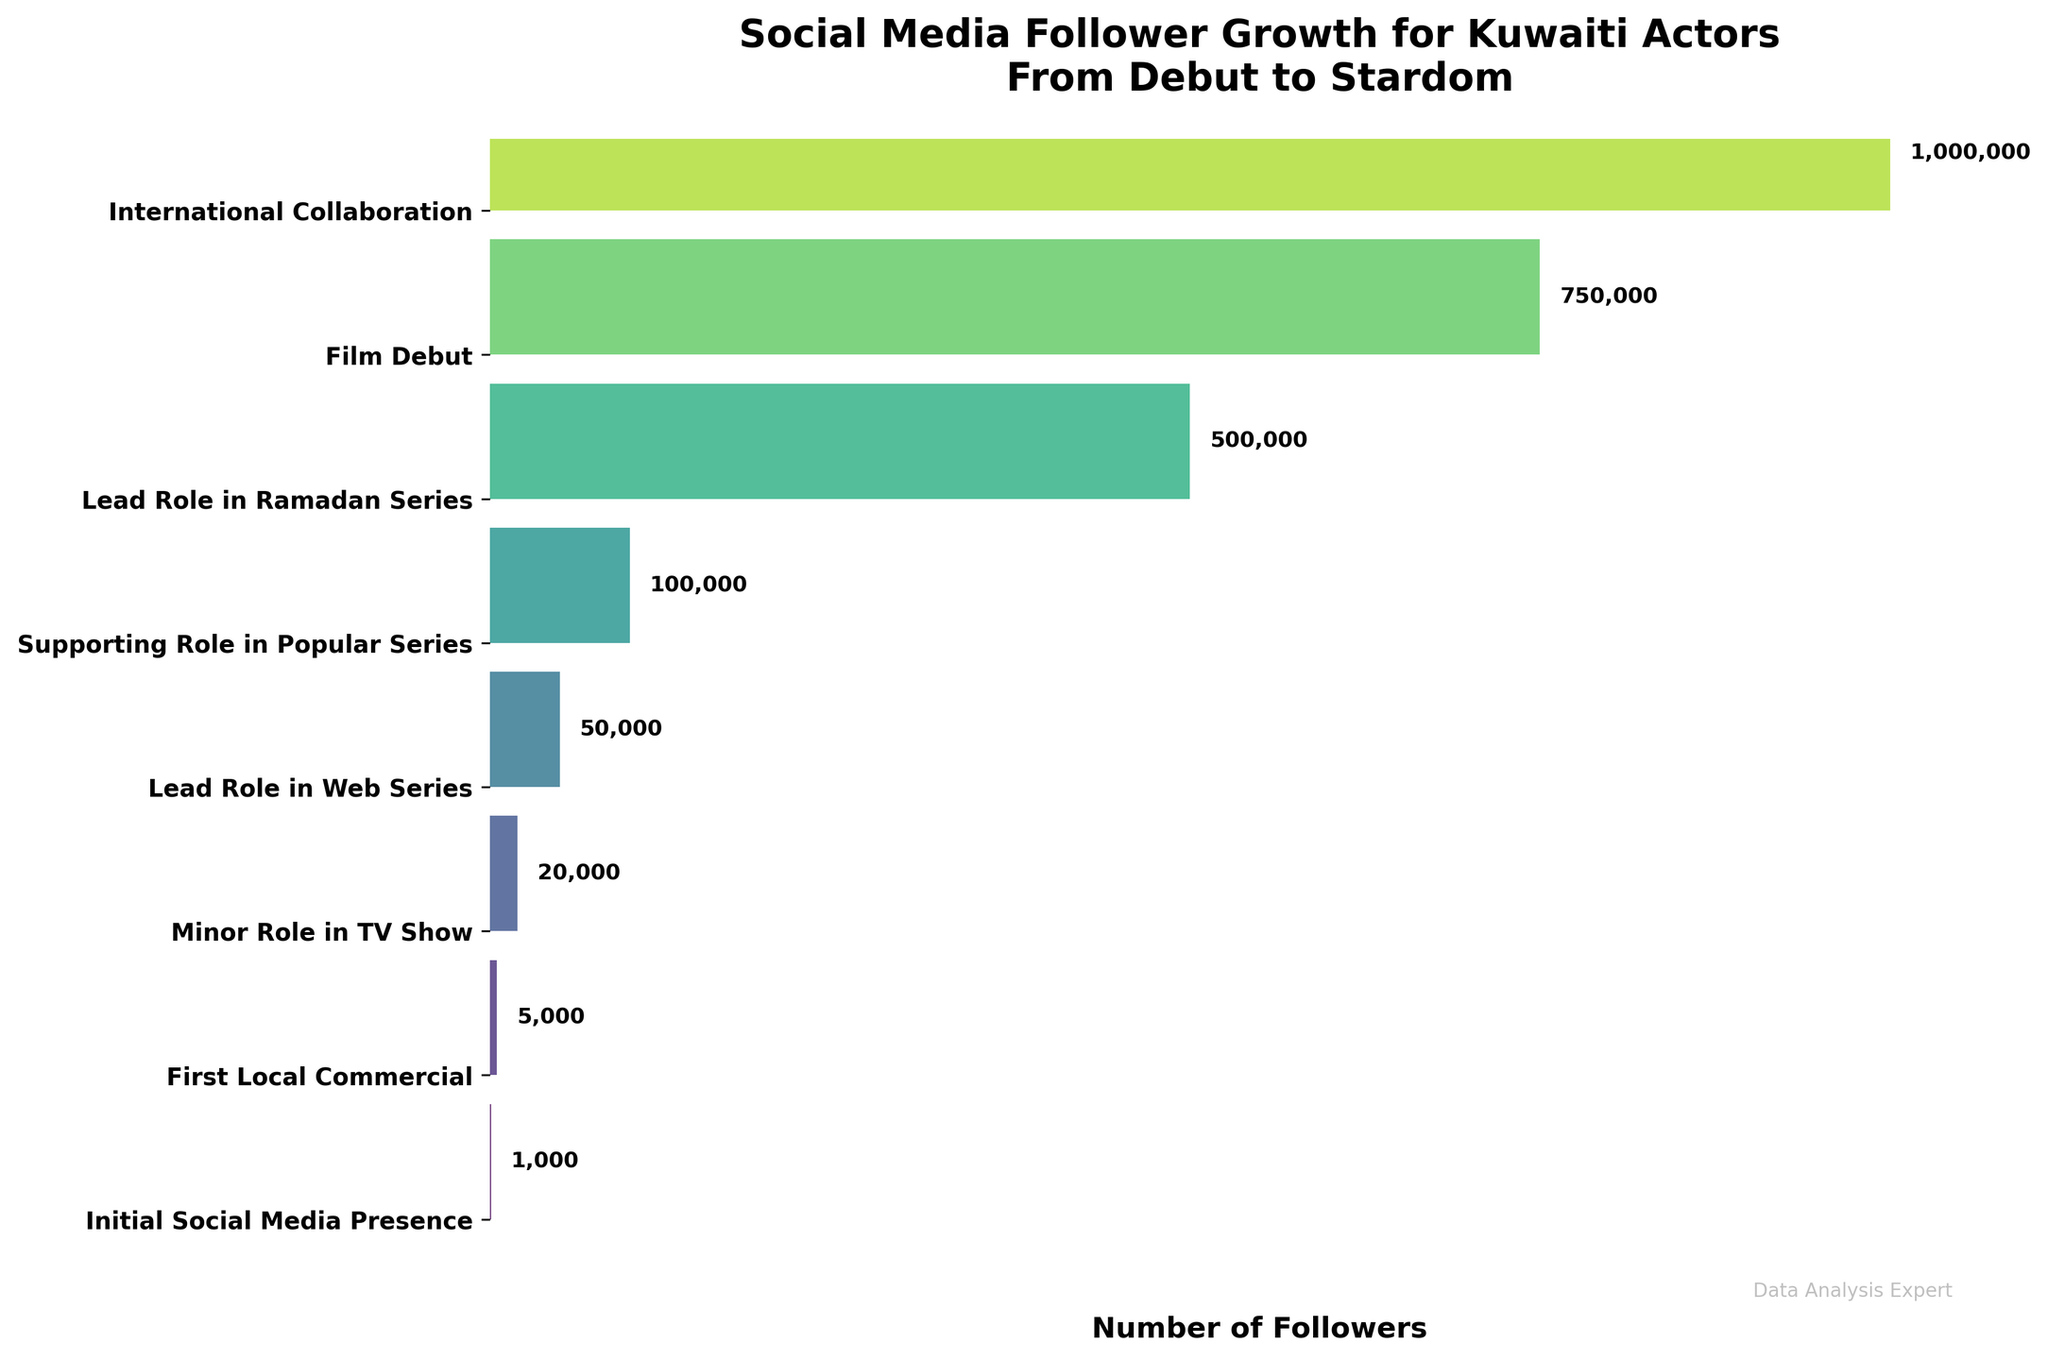How many average followers did Kuwaiti actors have when they made their film debut? Look at the "Film Debut" stage and read the corresponding average followers value from the chart.
Answer: 750,000 At which stage do Kuwaiti actors have an average of 100,000 followers? Identify the stage where the chart shows an average followers count of 100,000.
Answer: Supporting Role in Popular Series How many followers do actors typically gain between their Initial Social Media Presence and their First Local Commercial? Subtract the number of followers at "Initial Social Media Presence" from the followers at "First Local Commercial". 5,000 (First Local Commercial) - 1,000 (Initial Social Media Presence) = 4,000
Answer: 4,000 What is the percentage increase in followers from a Minor Role in a TV Show to a Lead Role in a Web Series? Calculate the percentage increase using the formula: ((New Value - Old Value) / Old Value) * 100. ((50,000 - 20,000) / 20,000) * 100 = 150%
Answer: 150% Compare the follower growth between Lead Role in Ramadan Series and International Collaboration. Which stage has more followers? Compare the follower values directly from the chart. 500,000 (Lead Role in Ramadan Series) < 1,000,000 (International Collaboration)
Answer: International Collaboration What’s the average number of followers from the Initial Social Media Presence to the Supporting Role in Popular Series? Add the followers for each stage within this range and divide by the number of stages. (1,000 + 5,000 + 20,000 + 50,000 + 100,000) / 5 = 35,200
Answer: 35,200 Which stage shows the largest increase in followers compared to the previous one? Calculate the difference in followers for each consecutive stage and identify the largest increase. 500,000 (Lead Role in Ramadan Series) - 100,000 (Supporting Role in Popular Series) = 400,000
Answer: Lead Role in Ramadan Series to Film Debut How many stages are depicted in the funnel chart? Count the total number of stages listed in the chart.
Answer: 8 